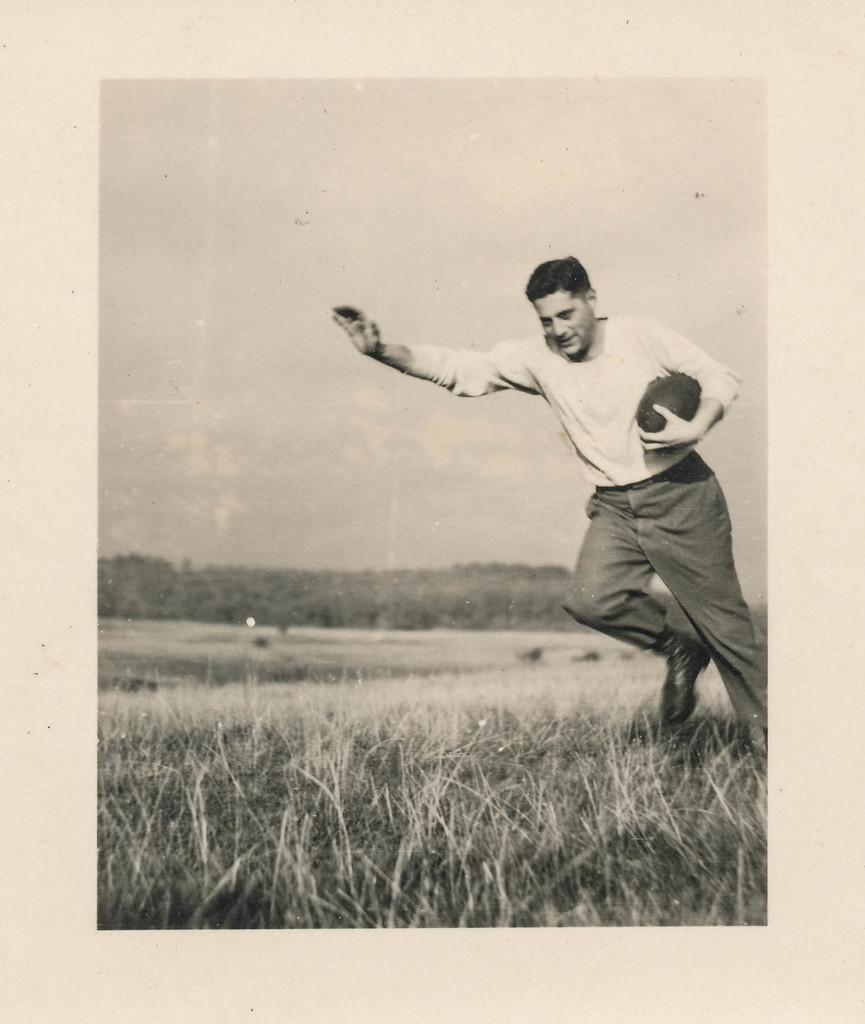What is the color scheme of the image? The image is black and white. What is the person in the image doing? The person is running on the ground. What is the person holding while running? The person is holding a ball. What type of vegetation can be seen in the background of the image? There are trees in the background of the image. What else is visible in the background of the image? There is grass and the sky visible in the background of the image. Can you tell me how many bananas are hanging from the trees in the image? There are no bananas visible in the image; only trees, grass, and the sky can be seen in the background. What type of goat can be seen grazing on the grass in the image? There are no goats present in the image; the person running is the only subject visible. 